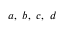Convert formula to latex. <formula><loc_0><loc_0><loc_500><loc_500>a , \ b , \ c , \ d</formula> 